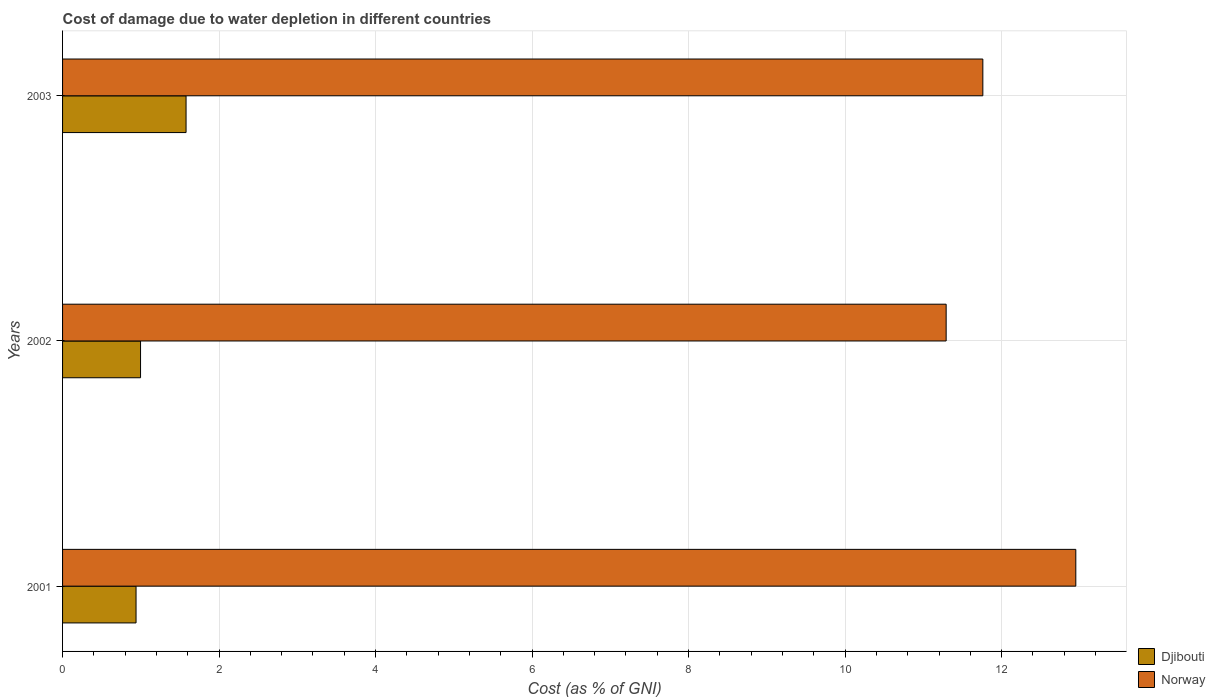How many different coloured bars are there?
Provide a succinct answer. 2. Are the number of bars per tick equal to the number of legend labels?
Your answer should be compact. Yes. How many bars are there on the 3rd tick from the top?
Provide a short and direct response. 2. What is the cost of damage caused due to water depletion in Djibouti in 2001?
Offer a terse response. 0.94. Across all years, what is the maximum cost of damage caused due to water depletion in Norway?
Offer a very short reply. 12.95. Across all years, what is the minimum cost of damage caused due to water depletion in Norway?
Give a very brief answer. 11.29. In which year was the cost of damage caused due to water depletion in Norway minimum?
Give a very brief answer. 2002. What is the total cost of damage caused due to water depletion in Norway in the graph?
Provide a short and direct response. 36. What is the difference between the cost of damage caused due to water depletion in Djibouti in 2001 and that in 2002?
Provide a short and direct response. -0.06. What is the difference between the cost of damage caused due to water depletion in Djibouti in 2003 and the cost of damage caused due to water depletion in Norway in 2002?
Offer a terse response. -9.71. What is the average cost of damage caused due to water depletion in Norway per year?
Offer a terse response. 12. In the year 2003, what is the difference between the cost of damage caused due to water depletion in Norway and cost of damage caused due to water depletion in Djibouti?
Provide a short and direct response. 10.18. What is the ratio of the cost of damage caused due to water depletion in Djibouti in 2002 to that in 2003?
Your answer should be compact. 0.63. What is the difference between the highest and the second highest cost of damage caused due to water depletion in Djibouti?
Keep it short and to the point. 0.58. What is the difference between the highest and the lowest cost of damage caused due to water depletion in Norway?
Provide a short and direct response. 1.66. Is the sum of the cost of damage caused due to water depletion in Norway in 2001 and 2003 greater than the maximum cost of damage caused due to water depletion in Djibouti across all years?
Offer a very short reply. Yes. What does the 2nd bar from the top in 2002 represents?
Keep it short and to the point. Djibouti. What does the 2nd bar from the bottom in 2001 represents?
Your response must be concise. Norway. How many bars are there?
Offer a very short reply. 6. Are all the bars in the graph horizontal?
Offer a terse response. Yes. Does the graph contain any zero values?
Your response must be concise. No. How are the legend labels stacked?
Your answer should be very brief. Vertical. What is the title of the graph?
Your answer should be very brief. Cost of damage due to water depletion in different countries. What is the label or title of the X-axis?
Make the answer very short. Cost (as % of GNI). What is the Cost (as % of GNI) in Djibouti in 2001?
Offer a very short reply. 0.94. What is the Cost (as % of GNI) of Norway in 2001?
Make the answer very short. 12.95. What is the Cost (as % of GNI) of Djibouti in 2002?
Give a very brief answer. 1. What is the Cost (as % of GNI) in Norway in 2002?
Offer a terse response. 11.29. What is the Cost (as % of GNI) of Djibouti in 2003?
Offer a terse response. 1.58. What is the Cost (as % of GNI) of Norway in 2003?
Ensure brevity in your answer.  11.76. Across all years, what is the maximum Cost (as % of GNI) in Djibouti?
Make the answer very short. 1.58. Across all years, what is the maximum Cost (as % of GNI) in Norway?
Keep it short and to the point. 12.95. Across all years, what is the minimum Cost (as % of GNI) of Djibouti?
Offer a terse response. 0.94. Across all years, what is the minimum Cost (as % of GNI) of Norway?
Your response must be concise. 11.29. What is the total Cost (as % of GNI) in Djibouti in the graph?
Keep it short and to the point. 3.51. What is the total Cost (as % of GNI) of Norway in the graph?
Provide a short and direct response. 36. What is the difference between the Cost (as % of GNI) in Djibouti in 2001 and that in 2002?
Offer a terse response. -0.06. What is the difference between the Cost (as % of GNI) in Norway in 2001 and that in 2002?
Your response must be concise. 1.66. What is the difference between the Cost (as % of GNI) in Djibouti in 2001 and that in 2003?
Make the answer very short. -0.64. What is the difference between the Cost (as % of GNI) of Norway in 2001 and that in 2003?
Make the answer very short. 1.19. What is the difference between the Cost (as % of GNI) in Djibouti in 2002 and that in 2003?
Your answer should be very brief. -0.58. What is the difference between the Cost (as % of GNI) in Norway in 2002 and that in 2003?
Provide a short and direct response. -0.47. What is the difference between the Cost (as % of GNI) in Djibouti in 2001 and the Cost (as % of GNI) in Norway in 2002?
Ensure brevity in your answer.  -10.35. What is the difference between the Cost (as % of GNI) of Djibouti in 2001 and the Cost (as % of GNI) of Norway in 2003?
Provide a short and direct response. -10.82. What is the difference between the Cost (as % of GNI) in Djibouti in 2002 and the Cost (as % of GNI) in Norway in 2003?
Your answer should be compact. -10.76. What is the average Cost (as % of GNI) of Djibouti per year?
Make the answer very short. 1.17. What is the average Cost (as % of GNI) in Norway per year?
Keep it short and to the point. 12. In the year 2001, what is the difference between the Cost (as % of GNI) in Djibouti and Cost (as % of GNI) in Norway?
Your response must be concise. -12.01. In the year 2002, what is the difference between the Cost (as % of GNI) of Djibouti and Cost (as % of GNI) of Norway?
Keep it short and to the point. -10.29. In the year 2003, what is the difference between the Cost (as % of GNI) of Djibouti and Cost (as % of GNI) of Norway?
Ensure brevity in your answer.  -10.18. What is the ratio of the Cost (as % of GNI) in Djibouti in 2001 to that in 2002?
Ensure brevity in your answer.  0.94. What is the ratio of the Cost (as % of GNI) in Norway in 2001 to that in 2002?
Give a very brief answer. 1.15. What is the ratio of the Cost (as % of GNI) of Djibouti in 2001 to that in 2003?
Give a very brief answer. 0.59. What is the ratio of the Cost (as % of GNI) in Norway in 2001 to that in 2003?
Offer a terse response. 1.1. What is the ratio of the Cost (as % of GNI) in Djibouti in 2002 to that in 2003?
Give a very brief answer. 0.63. What is the ratio of the Cost (as % of GNI) of Norway in 2002 to that in 2003?
Make the answer very short. 0.96. What is the difference between the highest and the second highest Cost (as % of GNI) in Djibouti?
Make the answer very short. 0.58. What is the difference between the highest and the second highest Cost (as % of GNI) of Norway?
Keep it short and to the point. 1.19. What is the difference between the highest and the lowest Cost (as % of GNI) of Djibouti?
Give a very brief answer. 0.64. What is the difference between the highest and the lowest Cost (as % of GNI) in Norway?
Your answer should be compact. 1.66. 